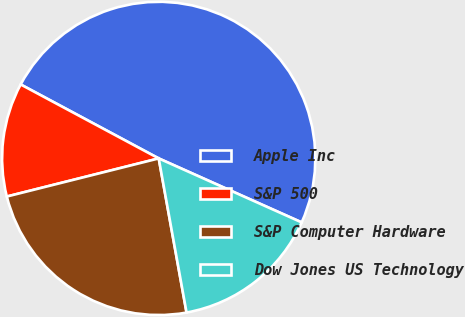Convert chart. <chart><loc_0><loc_0><loc_500><loc_500><pie_chart><fcel>Apple Inc<fcel>S&P 500<fcel>S&P Computer Hardware<fcel>Dow Jones US Technology<nl><fcel>48.87%<fcel>11.74%<fcel>23.93%<fcel>15.46%<nl></chart> 